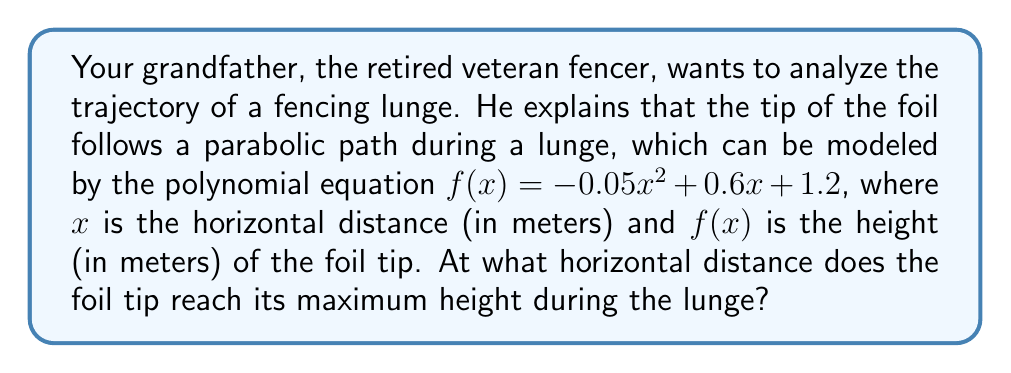Could you help me with this problem? To find the maximum height of the parabolic trajectory, we need to determine the vertex of the parabola. For a quadratic function in the form $f(x) = ax^2 + bx + c$, the x-coordinate of the vertex is given by $x = -\frac{b}{2a}$.

Given equation: $f(x) = -0.05x^2 + 0.6x + 1.2$

1) Identify the coefficients:
   $a = -0.05$
   $b = 0.6$
   $c = 1.2$

2) Calculate the x-coordinate of the vertex:
   $x = -\frac{b}{2a} = -\frac{0.6}{2(-0.05)} = -\frac{0.6}{-0.1} = 6$

Therefore, the foil tip reaches its maximum height when the horizontal distance is 6 meters.

To verify, we can calculate the derivative of $f(x)$ and set it to zero:

3) $f'(x) = -0.1x + 0.6$
   Set $f'(x) = 0$:
   $-0.1x + 0.6 = 0$
   $-0.1x = -0.6$
   $x = 6$

This confirms our result.
Answer: 6 meters 